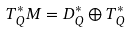<formula> <loc_0><loc_0><loc_500><loc_500>T _ { Q } ^ { * } M = D _ { Q } ^ { * } \oplus T _ { Q } ^ { * }</formula> 